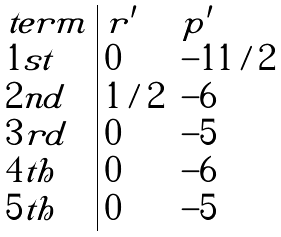<formula> <loc_0><loc_0><loc_500><loc_500>\begin{array} { l | l l } t e r m & r ^ { \prime } & p ^ { \prime } \\ 1 s t & 0 & - 1 1 / 2 \\ 2 n d & 1 / 2 & - 6 \\ 3 r d & 0 & - 5 \\ 4 t h & 0 & - 6 \\ 5 t h & 0 & - 5 \end{array}</formula> 